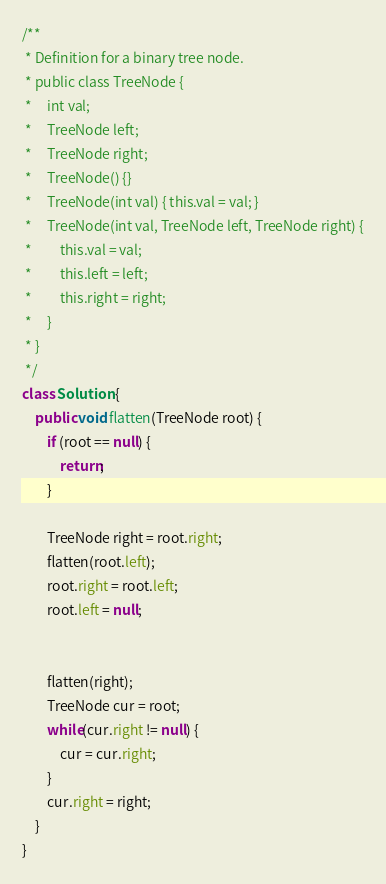Convert code to text. <code><loc_0><loc_0><loc_500><loc_500><_Java_>/**
 * Definition for a binary tree node.
 * public class TreeNode {
 *     int val;
 *     TreeNode left;
 *     TreeNode right;
 *     TreeNode() {}
 *     TreeNode(int val) { this.val = val; }
 *     TreeNode(int val, TreeNode left, TreeNode right) {
 *         this.val = val;
 *         this.left = left;
 *         this.right = right;
 *     }
 * }
 */
class Solution {
    public void flatten(TreeNode root) {
        if (root == null) {
            return;
        }

        TreeNode right = root.right;        
        flatten(root.left);
        root.right = root.left;
        root.left = null;


        flatten(right);
        TreeNode cur = root;
        while(cur.right != null) {
            cur = cur.right;
        }
        cur.right = right;
    }
}
</code> 